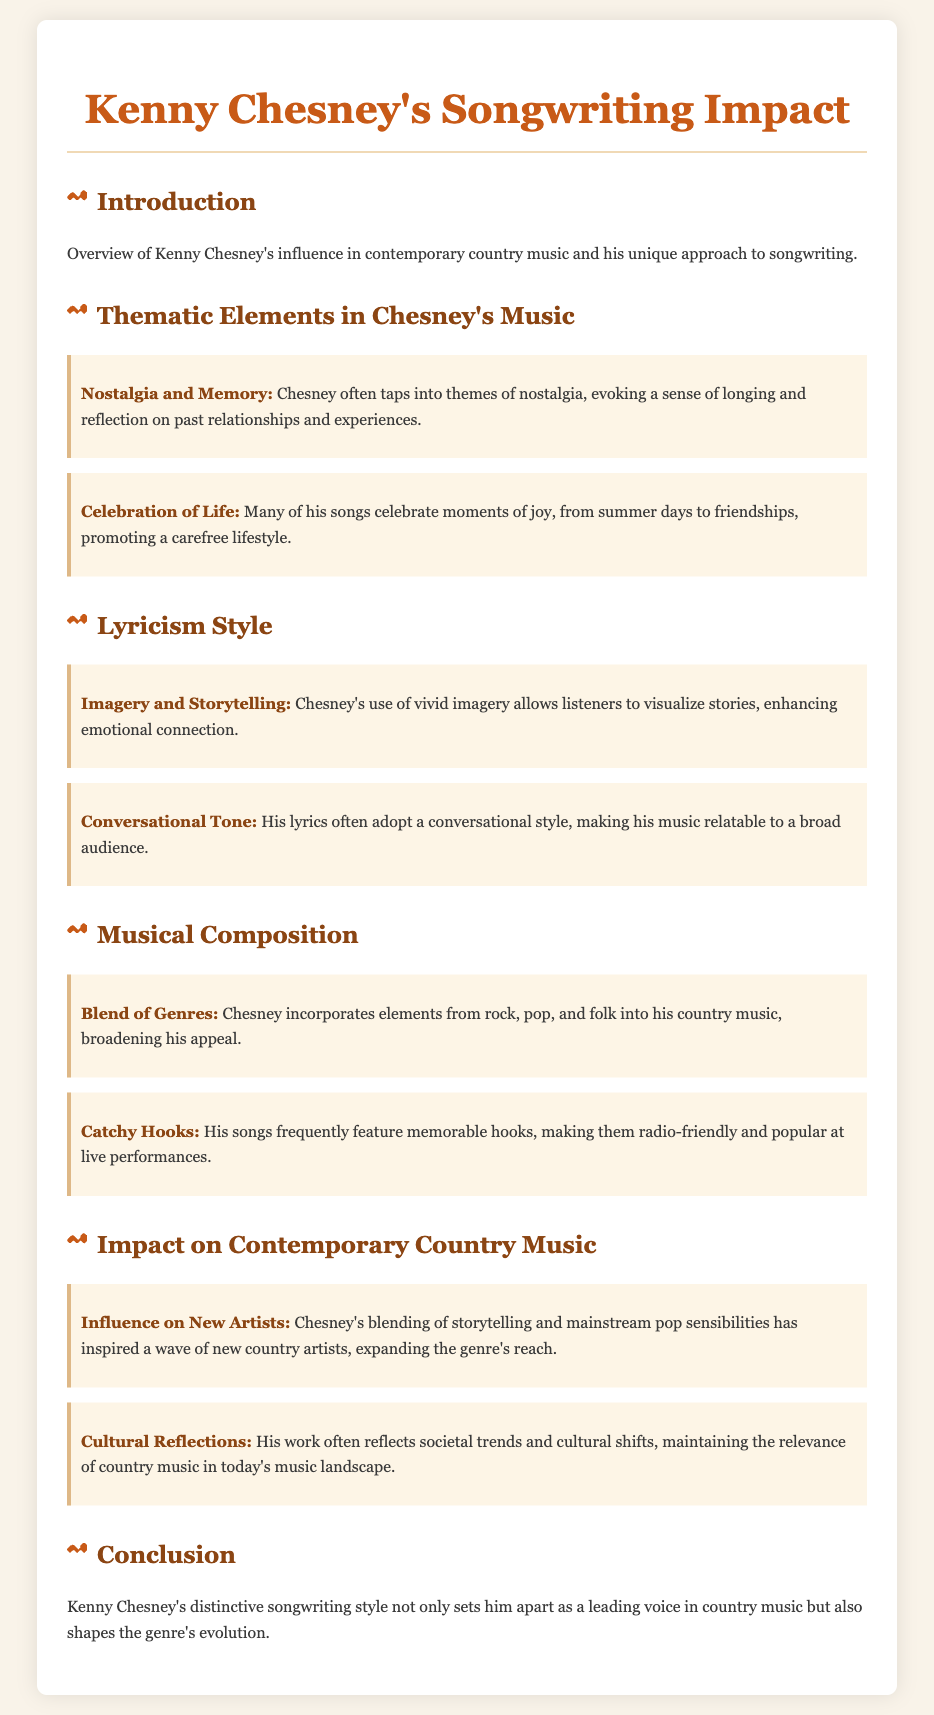what musical elements does Chesney incorporate? Chesney incorporates elements from rock, pop, and folk into his country music, broadening his appeal.
Answer: rock, pop, and folk what thematic element evokes nostalgia in Chesney's music? The thematic element that evokes nostalgia in Chesney's music is reflected in his focus on longing and reflection on past relationships and experiences.
Answer: Nostalgia and Memory how does Chesney's lyricism adapt to the audience? Chesney's lyricism adopts a conversational style, making his music relatable to a broad audience.
Answer: Conversational Tone what is a common feature of Chesney's songs that contributes to their popularity? A common feature that contributes to the popularity of Chesney's songs is their memorable hooks, making them radio-friendly and popular at live performances.
Answer: Catchy Hooks who has been influenced by Chesney's songwriting style? Chesney's blending of storytelling and mainstream pop sensibilities has inspired a wave of new country artists.
Answer: new country artists what does Chesney celebrate in his songwriting? Chesney celebrates moments of joy, promoting a carefree lifestyle.
Answer: Celebration of Life how does Kenny Chesney's music reflect cultural trends? His work often reflects societal trends and cultural shifts, maintaining the relevance of country music in today's music landscape.
Answer: Cultural Reflections what type of impact does Chesney's songwriting have on country music? Chesney's distinctive songwriting style shapes the genre's evolution.
Answer: shapes the genre's evolution what is an example of Chesney's thematic focus in his songs? An example of Chesney's thematic focus in his songs is evoking a sense of longing and reflection on past experiences.
Answer: Nostalgia and Memory what does the introduction provide? The introduction provides an overview of Kenny Chesney's influence in contemporary country music and his unique approach to songwriting.
Answer: overview of Kenny Chesney's influence 